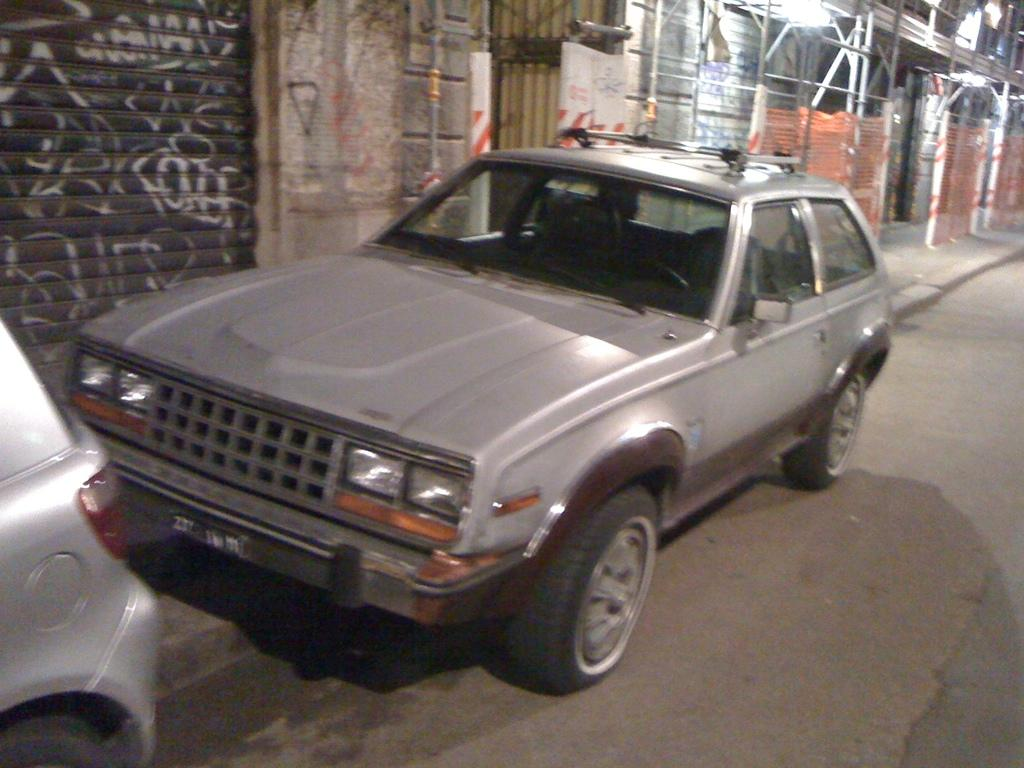What can be seen on the road in the image? There are motor vehicles on the road in the image. What is visible in the background of the image? There are buildings and grills in the background of the image. Where is the pipe located in the image? There is no pipe present in the image. What type of mailbox can be seen near the grills in the image? There is no mailbox present in the image. 